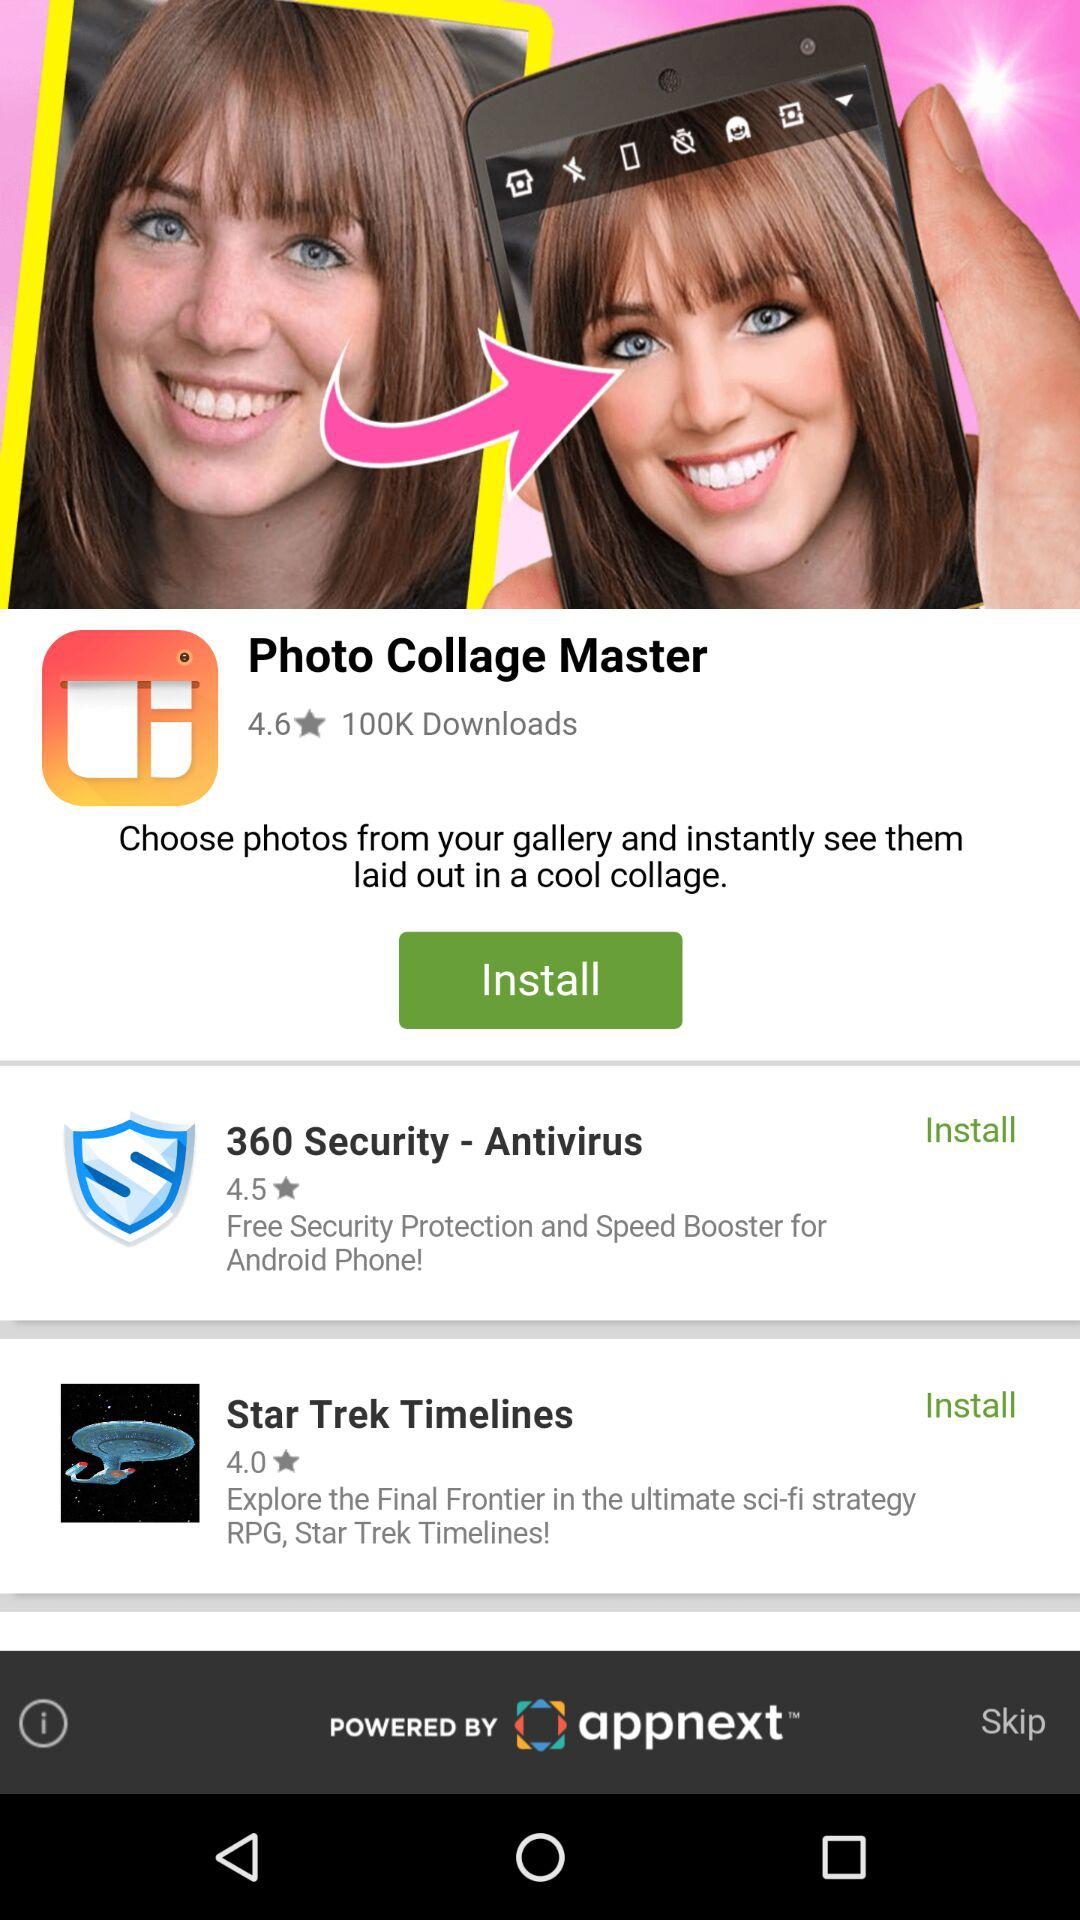What application has received 100K downloads? The application that has received 100K downloads is "Photo Collage Master". 